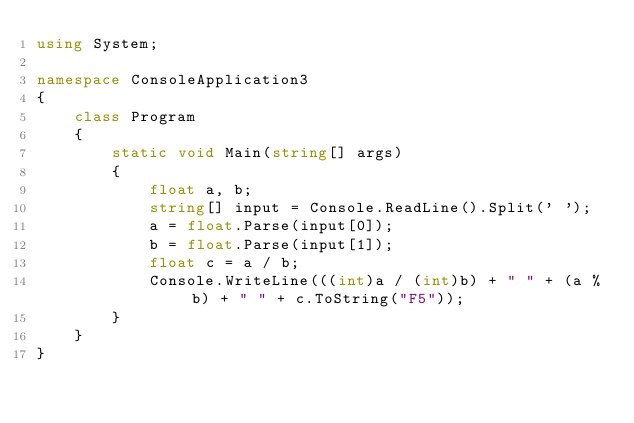<code> <loc_0><loc_0><loc_500><loc_500><_C#_>using System;

namespace ConsoleApplication3
{
    class Program
    {
        static void Main(string[] args)
        {
            float a, b;
            string[] input = Console.ReadLine().Split(' ');
            a = float.Parse(input[0]);
            b = float.Parse(input[1]);
            float c = a / b;
            Console.WriteLine(((int)a / (int)b) + " " + (a % b) + " " + c.ToString("F5"));
        }
    }
}</code> 